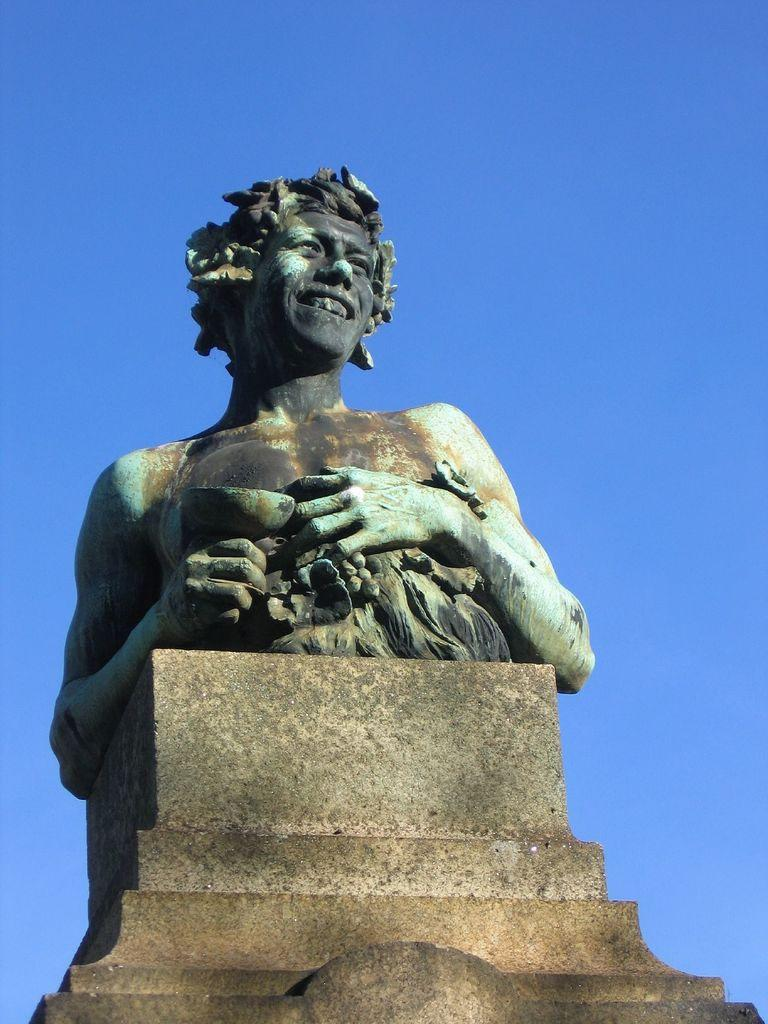What is the main subject of the image? There is a statue in the image. Where is the statue located? The statue is on a platform. What can be seen in the background of the image? The sky is visible in the background of the image. How many flowers are surrounding the statue in the image? There are no flowers present in the image; it only features a statue on a platform with the sky visible in the background. 